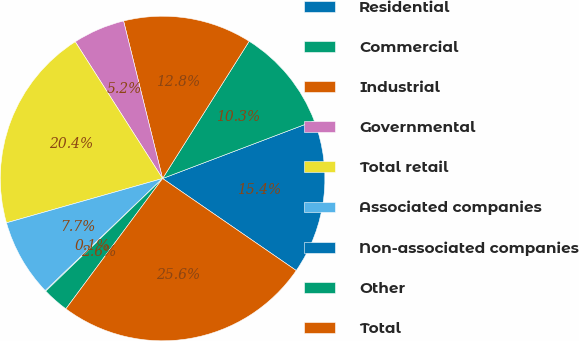Convert chart. <chart><loc_0><loc_0><loc_500><loc_500><pie_chart><fcel>Residential<fcel>Commercial<fcel>Industrial<fcel>Governmental<fcel>Total retail<fcel>Associated companies<fcel>Non-associated companies<fcel>Other<fcel>Total<nl><fcel>15.37%<fcel>10.27%<fcel>12.82%<fcel>5.18%<fcel>20.36%<fcel>7.73%<fcel>0.08%<fcel>2.63%<fcel>25.56%<nl></chart> 